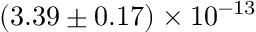Convert formula to latex. <formula><loc_0><loc_0><loc_500><loc_500>( 3 . 3 9 \pm 0 . 1 7 ) \times 1 0 ^ { - 1 3 }</formula> 